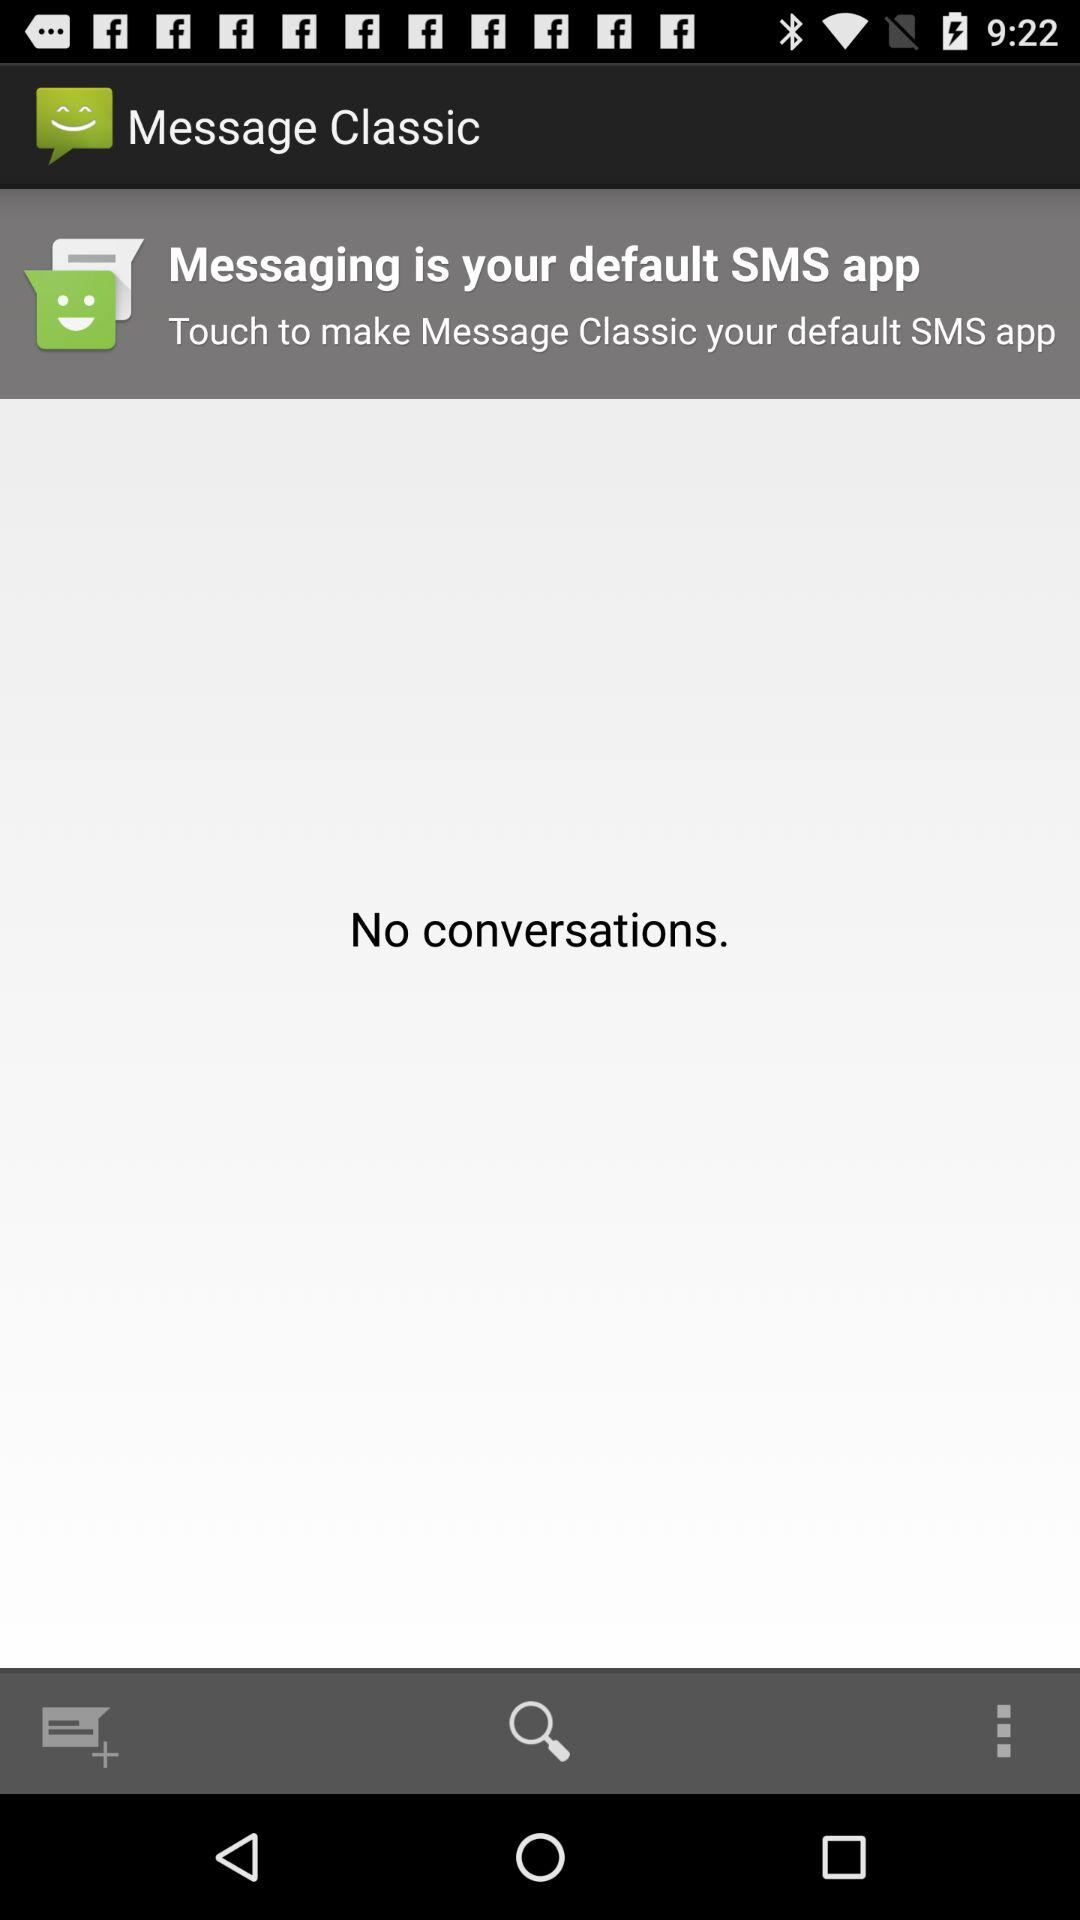What is the name of the application? The name of the application is "Message Classic". 